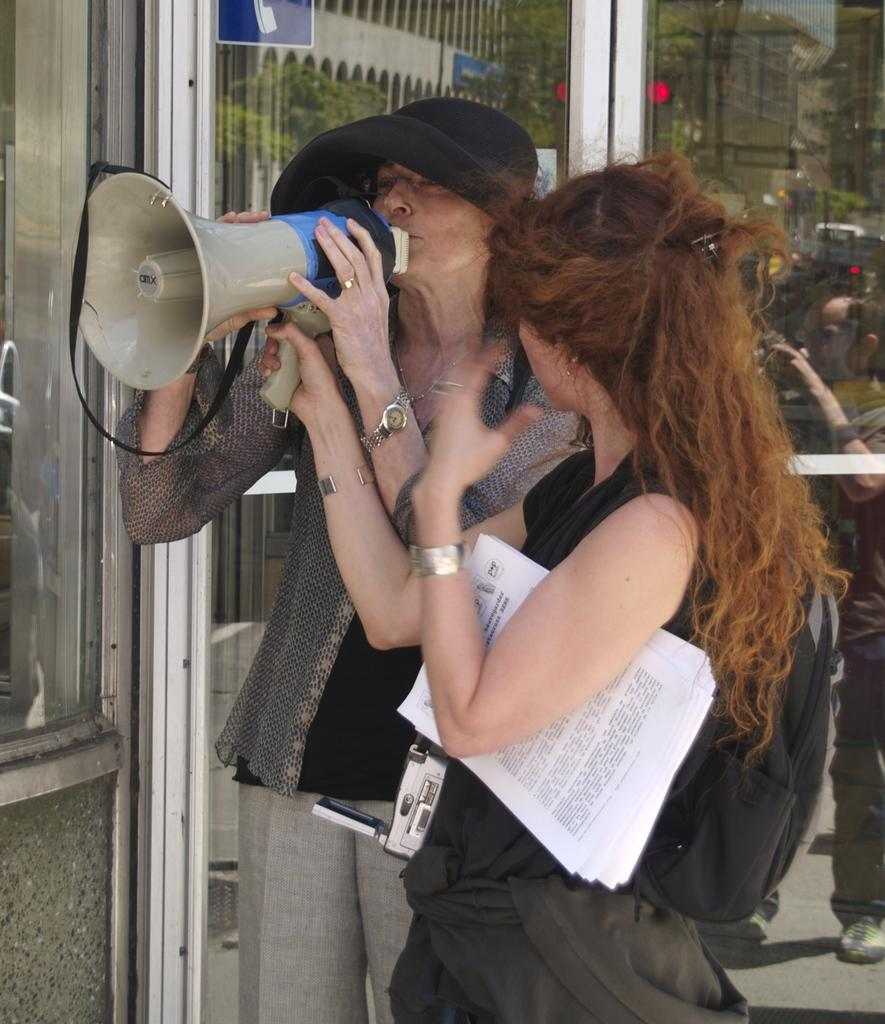What is the woman in the image holding? The woman is holding a mic in the image. What is the woman doing with the mic? The woman is speaking on the mic. What is the other lady in the image holding? The other lady is holding papers in the image. What can be seen in the background of the image? There is a glass door in the background of the image. How many jellyfish are swimming in the background of the image? There are no jellyfish present in the image; it features two ladies and a glass door in the background. What type of tomatoes can be seen growing near the ladies in the image? There are no tomatoes visible in the image. 